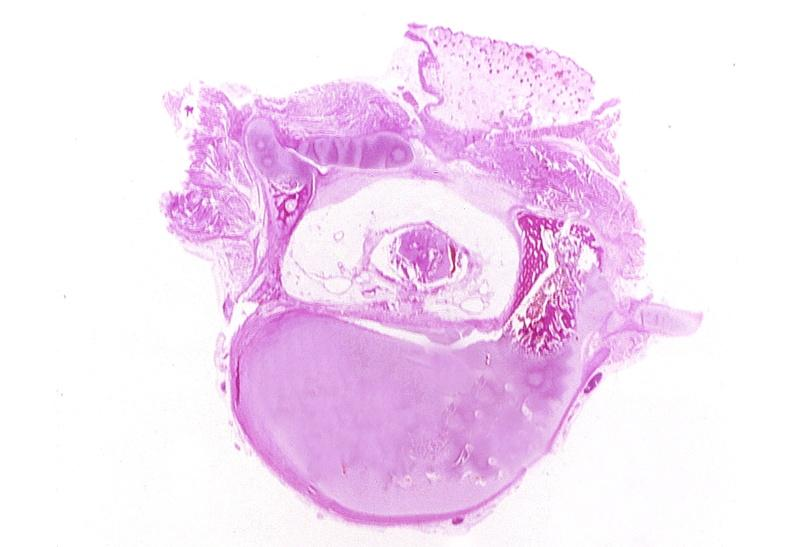s choanal patency present?
Answer the question using a single word or phrase. No 